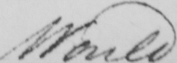Can you read and transcribe this handwriting? Would 